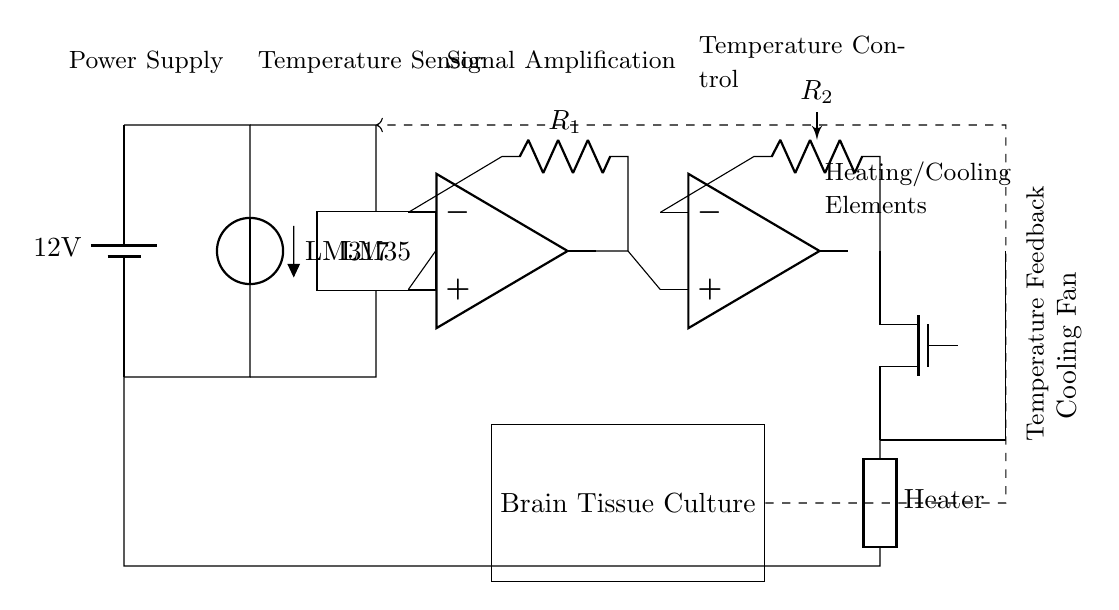What is the power supply voltage? The circuit diagram indicates a battery with a voltage of 12 volts, which is specified on the power supply component.
Answer: 12 volts What component is used for temperature sensing? The diagram clearly labels the temperature sensor as LM35, which is a standard component for temperature measurements.
Answer: LM35 How is temperature feedback implemented in this circuit? The dashed line labeled "Temperature Feedback" indicates that the brain tissue culture chamber is connected to the op-amp, creating a feedback loop to regulate temperature based on the sensor's output.
Answer: Feedback loop What components are involved in the heating and cooling mechanism? The circuit shows a MOSFET (for control) connected to both a heater and a cooling fan, which indicates how temperature can be adjusted either by heating or cooling.
Answer: Heater and Cooling Fan What is the function of the operational amplifier in this circuit? The operational amplifier amplifies the voltage signal from the temperature sensor, allowing for more accurate readings and better control over the heating and cooling elements.
Answer: Signal amplification Which component acts as a comparator in this circuit? The diagram includes a second operational amplifier that takes inputs from the amplified signal and a reference voltage to determine the action needed (heat or cool). This component functions as a comparator for temperature regulation.
Answer: Comparator What role does the resistor play in the op-amp circuit? The resistors, labeled R1 and R2, create a gain for the op-amp circuit which is essential in setting the threshold for triggering the heating or cooling based on voltage levels from the sensor.
Answer: Gain control 